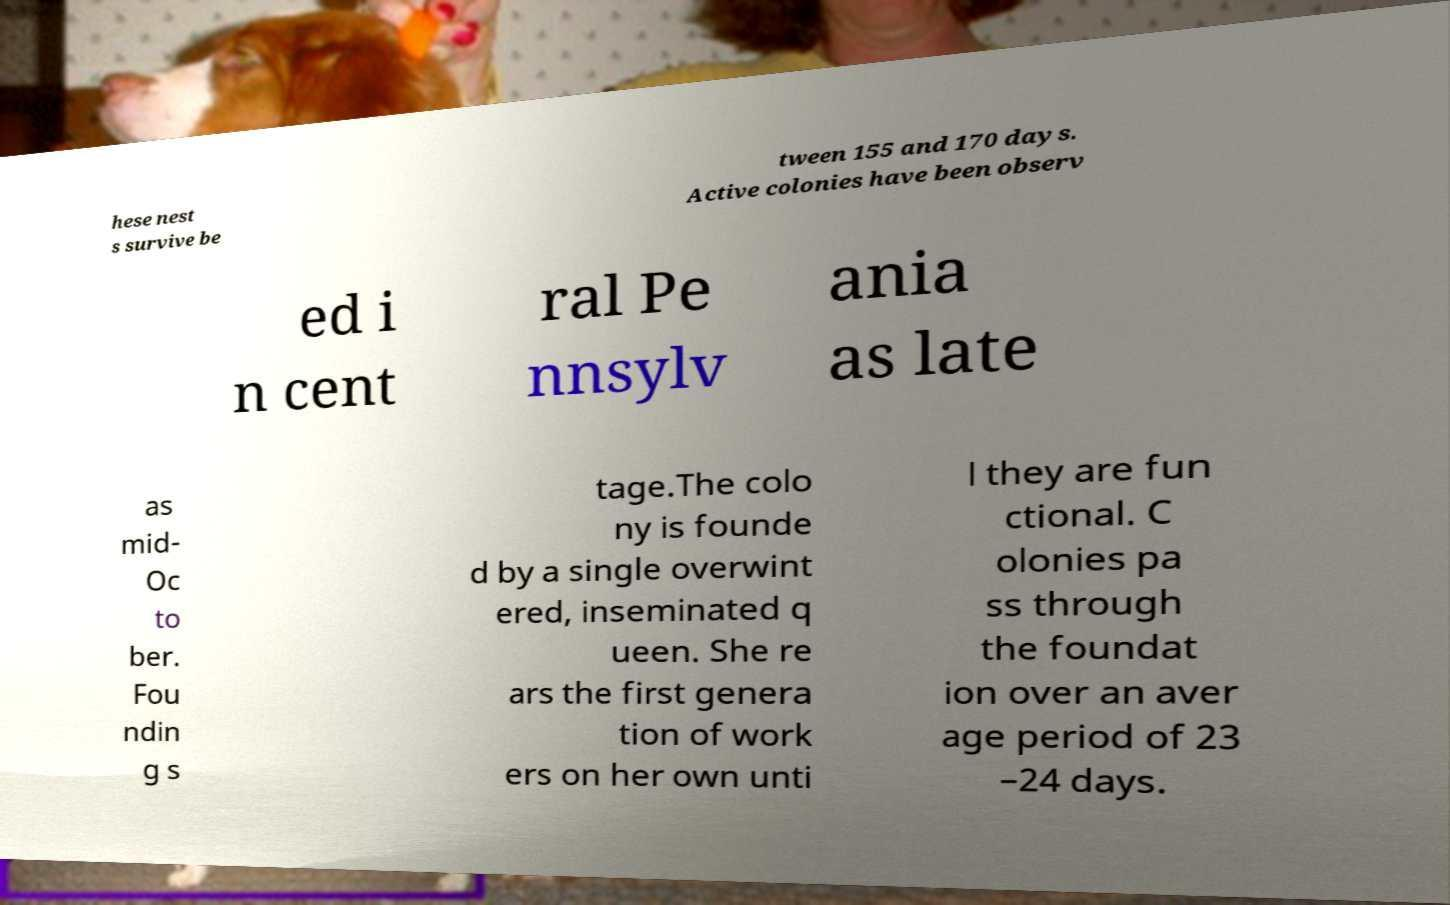Please identify and transcribe the text found in this image. hese nest s survive be tween 155 and 170 days. Active colonies have been observ ed i n cent ral Pe nnsylv ania as late as mid- Oc to ber. Fou ndin g s tage.The colo ny is founde d by a single overwint ered, inseminated q ueen. She re ars the first genera tion of work ers on her own unti l they are fun ctional. C olonies pa ss through the foundat ion over an aver age period of 23 –24 days. 